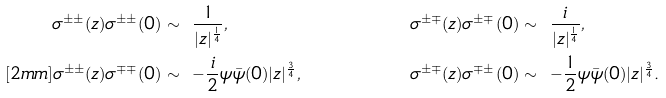<formula> <loc_0><loc_0><loc_500><loc_500>\sigma ^ { \pm \pm } ( z ) \sigma ^ { \pm \pm } ( 0 ) & \sim \ \frac { 1 } { | z | ^ { \frac { 1 } { 4 } } } , & \sigma ^ { \pm \mp } ( z ) \sigma ^ { \pm \mp } ( 0 ) & \sim \ \frac { i } { | z | ^ { \frac { 1 } { 4 } } } , \\ [ 2 m m ] \sigma ^ { \pm \pm } ( z ) \sigma ^ { \mp \mp } ( 0 ) & \sim \ - \frac { i } { 2 } \psi \bar { \psi } ( 0 ) | z | ^ { \frac { 3 } { 4 } } , & \sigma ^ { \pm \mp } ( z ) \sigma ^ { \mp \pm } ( 0 ) & \sim \ - \frac { 1 } { 2 } \psi \bar { \psi } ( 0 ) | z | ^ { \frac { 3 } { 4 } } .</formula> 